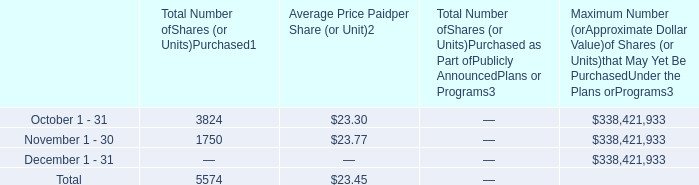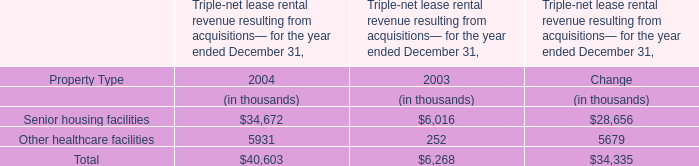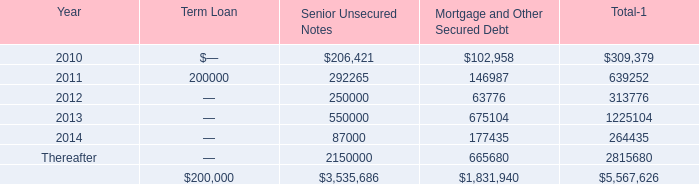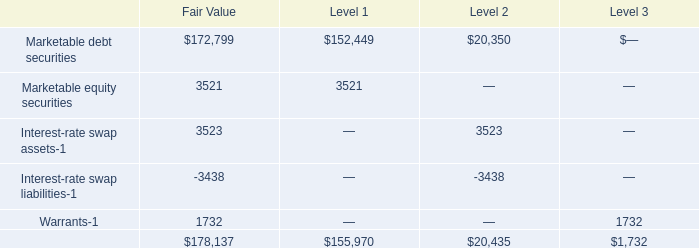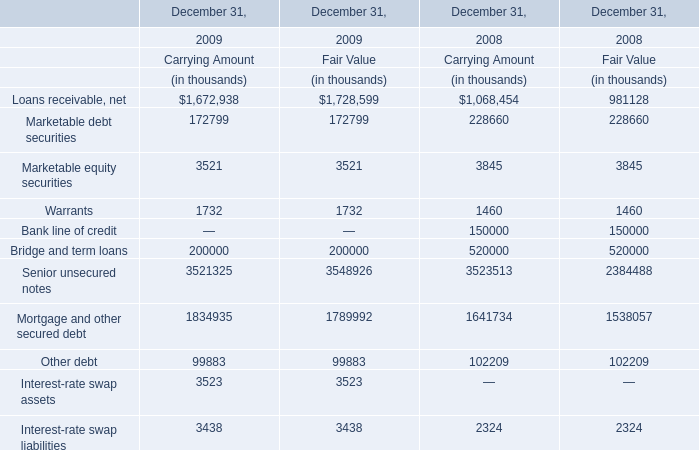Which year is Bridge and term loans at Fair Value lower? 
Answer: 2009. 